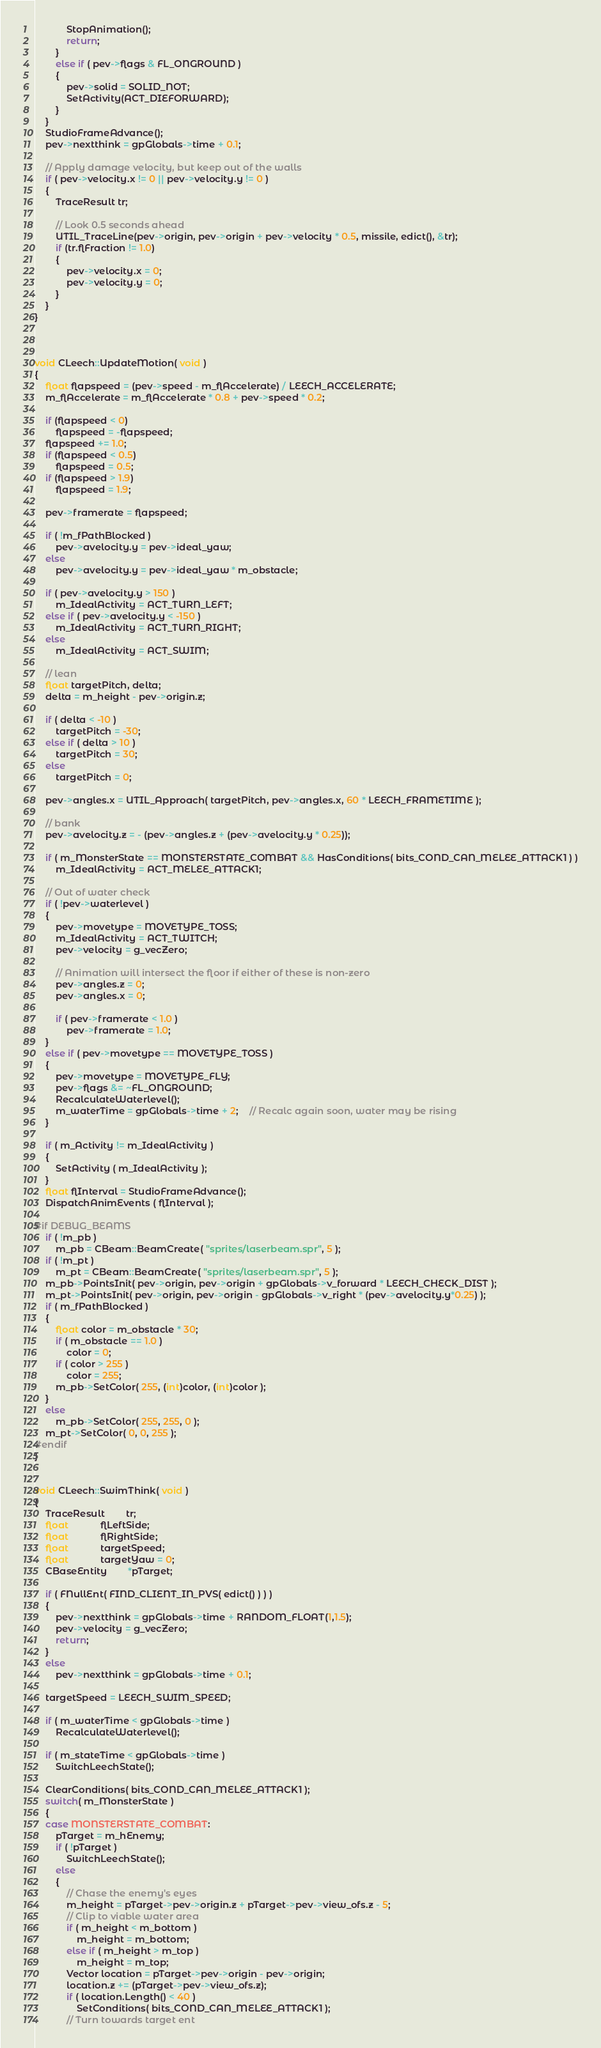<code> <loc_0><loc_0><loc_500><loc_500><_C++_>			StopAnimation();
			return;
		}
		else if ( pev->flags & FL_ONGROUND )
		{
			pev->solid = SOLID_NOT;
			SetActivity(ACT_DIEFORWARD);
		}
	}
	StudioFrameAdvance();
	pev->nextthink = gpGlobals->time + 0.1;

	// Apply damage velocity, but keep out of the walls
	if ( pev->velocity.x != 0 || pev->velocity.y != 0 )
	{
		TraceResult tr;

		// Look 0.5 seconds ahead
		UTIL_TraceLine(pev->origin, pev->origin + pev->velocity * 0.5, missile, edict(), &tr);
		if (tr.flFraction != 1.0)
		{
			pev->velocity.x = 0;
			pev->velocity.y = 0;
		}
	}
}



void CLeech::UpdateMotion( void )
{
	float flapspeed = (pev->speed - m_flAccelerate) / LEECH_ACCELERATE;
	m_flAccelerate = m_flAccelerate * 0.8 + pev->speed * 0.2;

	if (flapspeed < 0) 
		flapspeed = -flapspeed;
	flapspeed += 1.0;
	if (flapspeed < 0.5) 
		flapspeed = 0.5;
	if (flapspeed > 1.9) 
		flapspeed = 1.9;

	pev->framerate = flapspeed;

	if ( !m_fPathBlocked )
		pev->avelocity.y = pev->ideal_yaw;
	else
		pev->avelocity.y = pev->ideal_yaw * m_obstacle;

	if ( pev->avelocity.y > 150 )
		m_IdealActivity = ACT_TURN_LEFT;
	else if ( pev->avelocity.y < -150 )
		m_IdealActivity = ACT_TURN_RIGHT;
	else
		m_IdealActivity = ACT_SWIM;

	// lean
	float targetPitch, delta;
	delta = m_height - pev->origin.z;

	if ( delta < -10 )
		targetPitch = -30;
	else if ( delta > 10 )
		targetPitch = 30;
	else
		targetPitch = 0;

	pev->angles.x = UTIL_Approach( targetPitch, pev->angles.x, 60 * LEECH_FRAMETIME );

	// bank
	pev->avelocity.z = - (pev->angles.z + (pev->avelocity.y * 0.25));

	if ( m_MonsterState == MONSTERSTATE_COMBAT && HasConditions( bits_COND_CAN_MELEE_ATTACK1 ) )
		m_IdealActivity = ACT_MELEE_ATTACK1;

	// Out of water check
	if ( !pev->waterlevel )
	{
		pev->movetype = MOVETYPE_TOSS;
		m_IdealActivity = ACT_TWITCH;
		pev->velocity = g_vecZero;

		// Animation will intersect the floor if either of these is non-zero
		pev->angles.z = 0;
		pev->angles.x = 0;

		if ( pev->framerate < 1.0 )
			pev->framerate = 1.0;
	}
	else if ( pev->movetype == MOVETYPE_TOSS )
	{
		pev->movetype = MOVETYPE_FLY;
		pev->flags &= ~FL_ONGROUND;
		RecalculateWaterlevel();
		m_waterTime = gpGlobals->time + 2;	// Recalc again soon, water may be rising
	}

	if ( m_Activity != m_IdealActivity )
	{
		SetActivity ( m_IdealActivity );
	}
	float flInterval = StudioFrameAdvance();
	DispatchAnimEvents ( flInterval );

#if DEBUG_BEAMS
	if ( !m_pb )
		m_pb = CBeam::BeamCreate( "sprites/laserbeam.spr", 5 );
	if ( !m_pt )
		m_pt = CBeam::BeamCreate( "sprites/laserbeam.spr", 5 );
	m_pb->PointsInit( pev->origin, pev->origin + gpGlobals->v_forward * LEECH_CHECK_DIST );
	m_pt->PointsInit( pev->origin, pev->origin - gpGlobals->v_right * (pev->avelocity.y*0.25) );
	if ( m_fPathBlocked )
	{
		float color = m_obstacle * 30;
		if ( m_obstacle == 1.0 )
			color = 0;
		if ( color > 255 )
			color = 255;
		m_pb->SetColor( 255, (int)color, (int)color );
	}
	else
		m_pb->SetColor( 255, 255, 0 );
	m_pt->SetColor( 0, 0, 255 );
#endif
}


void CLeech::SwimThink( void )
{
	TraceResult		tr;
	float			flLeftSide;
	float			flRightSide;
	float			targetSpeed;
	float			targetYaw = 0;
	CBaseEntity		*pTarget;

	if ( FNullEnt( FIND_CLIENT_IN_PVS( edict() ) ) )
	{
		pev->nextthink = gpGlobals->time + RANDOM_FLOAT(1,1.5);
		pev->velocity = g_vecZero;
		return;
	}
	else
		pev->nextthink = gpGlobals->time + 0.1;

	targetSpeed = LEECH_SWIM_SPEED;

	if ( m_waterTime < gpGlobals->time )
		RecalculateWaterlevel();

	if ( m_stateTime < gpGlobals->time )
		SwitchLeechState();

	ClearConditions( bits_COND_CAN_MELEE_ATTACK1 );
	switch( m_MonsterState )
	{
	case MONSTERSTATE_COMBAT:
		pTarget = m_hEnemy;
		if ( !pTarget )
			SwitchLeechState();
		else
		{
			// Chase the enemy's eyes
			m_height = pTarget->pev->origin.z + pTarget->pev->view_ofs.z - 5;
			// Clip to viable water area
			if ( m_height < m_bottom )
				m_height = m_bottom;
			else if ( m_height > m_top )
				m_height = m_top;
			Vector location = pTarget->pev->origin - pev->origin;
			location.z += (pTarget->pev->view_ofs.z);
			if ( location.Length() < 40 )
				SetConditions( bits_COND_CAN_MELEE_ATTACK1 );
			// Turn towards target ent</code> 